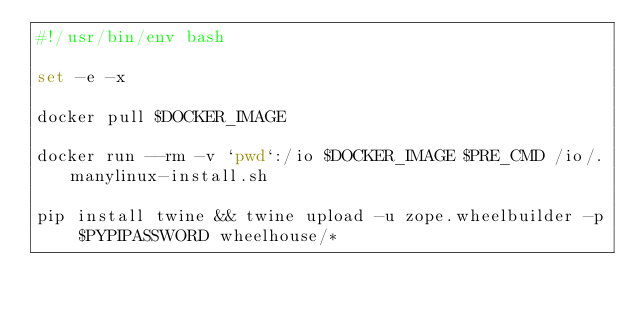Convert code to text. <code><loc_0><loc_0><loc_500><loc_500><_Bash_>#!/usr/bin/env bash

set -e -x

docker pull $DOCKER_IMAGE

docker run --rm -v `pwd`:/io $DOCKER_IMAGE $PRE_CMD /io/.manylinux-install.sh

pip install twine && twine upload -u zope.wheelbuilder -p $PYPIPASSWORD wheelhouse/*
</code> 